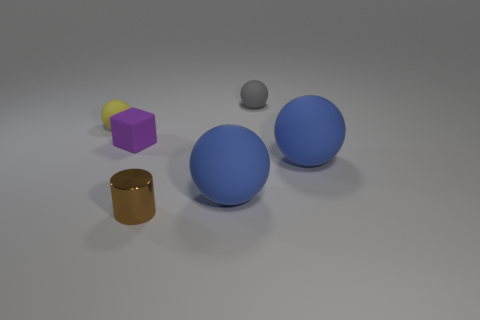Subtract all gray spheres. How many spheres are left? 3 Subtract 1 blocks. How many blocks are left? 0 Subtract all yellow spheres. How many spheres are left? 3 Add 4 brown shiny things. How many objects exist? 10 Subtract 0 yellow cylinders. How many objects are left? 6 Subtract all cubes. How many objects are left? 5 Subtract all green spheres. Subtract all red cylinders. How many spheres are left? 4 Subtract all brown cubes. How many gray balls are left? 1 Subtract all small cyan objects. Subtract all tiny gray things. How many objects are left? 5 Add 2 purple blocks. How many purple blocks are left? 3 